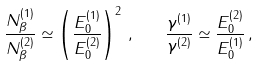<formula> <loc_0><loc_0><loc_500><loc_500>\frac { N _ { \beta } ^ { ( 1 ) } } { N _ { \beta } ^ { ( 2 ) } } \simeq \left ( \frac { E _ { 0 } ^ { ( 1 ) } } { E _ { 0 } ^ { ( 2 ) } } \right ) ^ { 2 } \, , \quad \frac { \gamma ^ { ( 1 ) } } { \gamma ^ { ( 2 ) } } \simeq \frac { E _ { 0 } ^ { ( 2 ) } } { E _ { 0 } ^ { ( 1 ) } } \, ,</formula> 